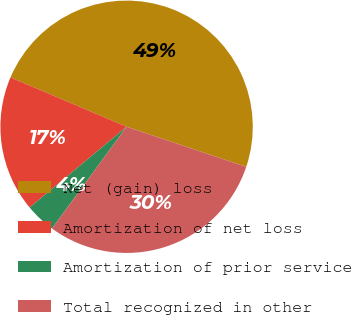Convert chart to OTSL. <chart><loc_0><loc_0><loc_500><loc_500><pie_chart><fcel>Net (gain) loss<fcel>Amortization of net loss<fcel>Amortization of prior service<fcel>Total recognized in other<nl><fcel>48.75%<fcel>17.45%<fcel>3.88%<fcel>29.92%<nl></chart> 